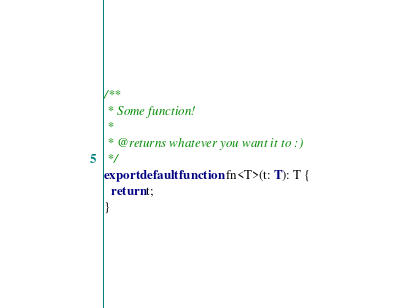Convert code to text. <code><loc_0><loc_0><loc_500><loc_500><_TypeScript_>/**
 * Some function!
 *
 * @returns whatever you want it to :)
 */
export default function fn<T>(t: T): T {
  return t;
}
</code> 